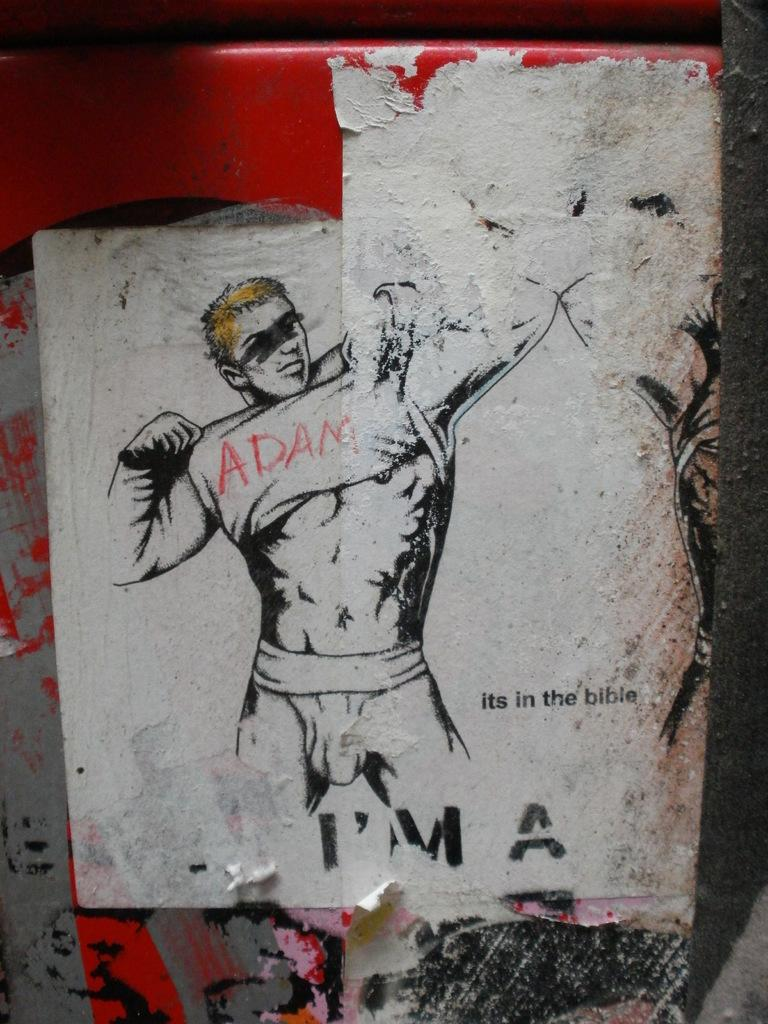What is on the wall in the image? There is a paper on the wall in the image. What is featured on the paper? The paper contains text and a cartoon image of a man. What type of attack is being carried out by the sun in the image? There is no sun or attack present in the image; it features a paper with text and a cartoon image of a man. 